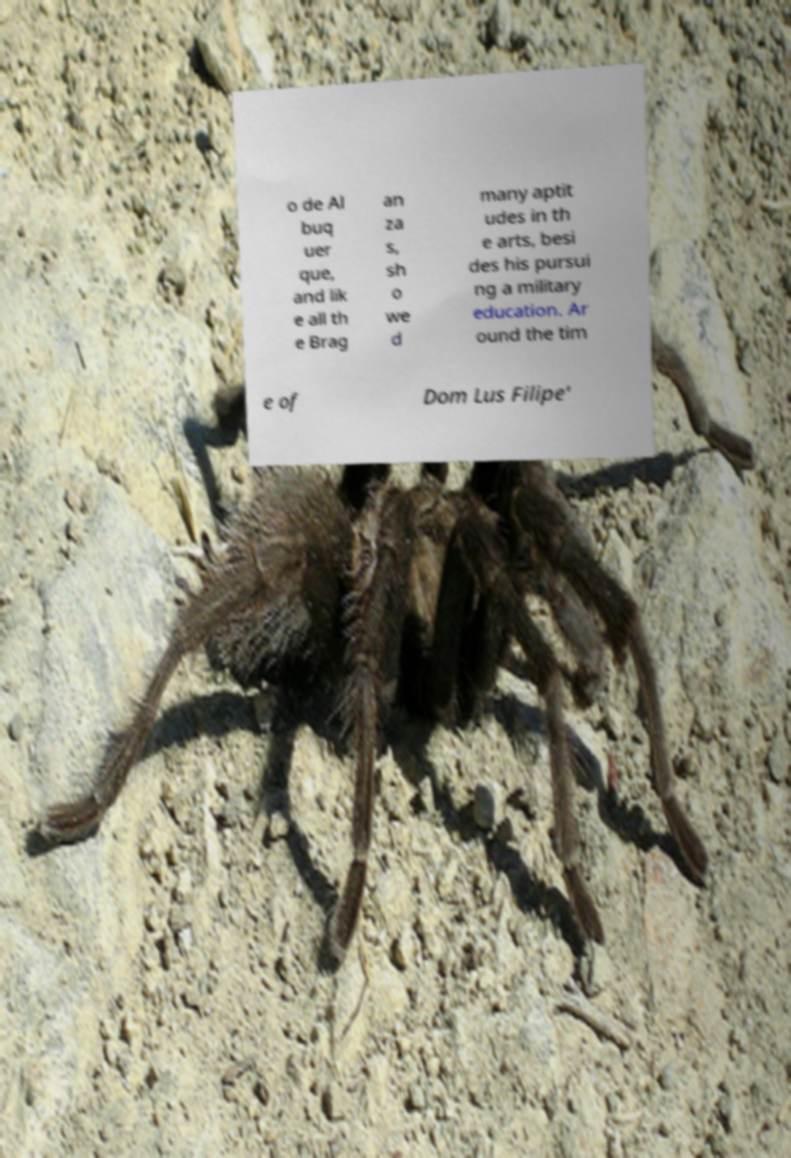I need the written content from this picture converted into text. Can you do that? o de Al buq uer que, and lik e all th e Brag an za s, sh o we d many aptit udes in th e arts, besi des his pursui ng a military education. Ar ound the tim e of Dom Lus Filipe' 